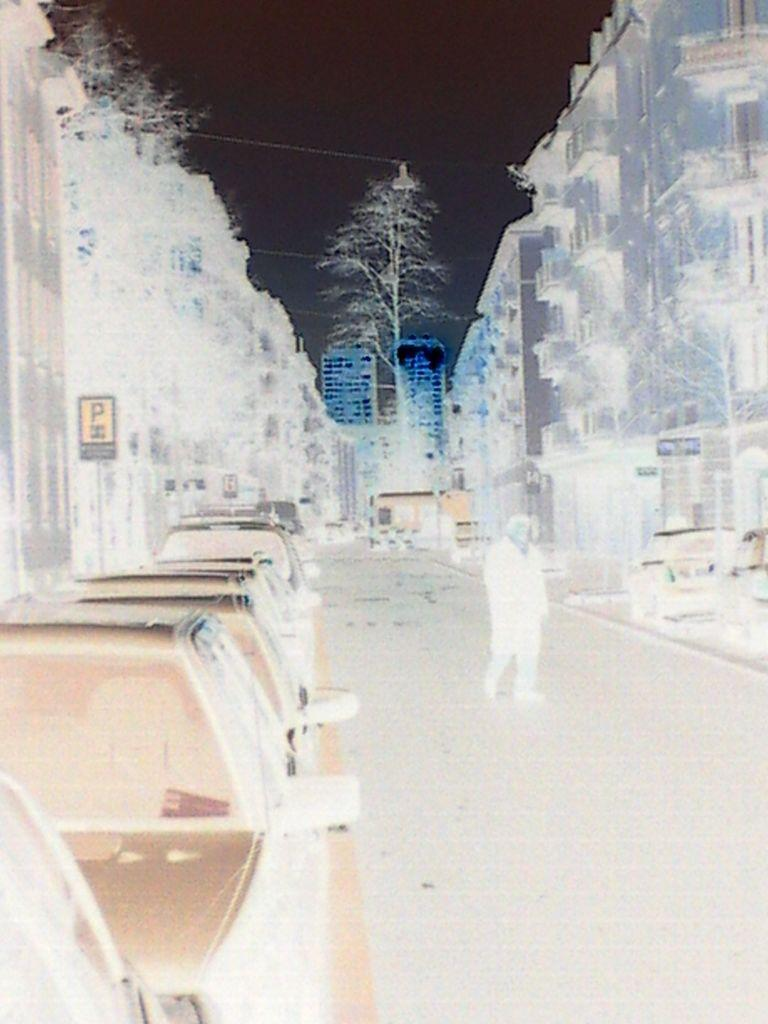What type of structures can be seen in the image? There are buildings in the image. What other natural elements are present in the image? There are trees in the image. Can you describe the lighting conditions in the image? There is light visible in the image. What part of the natural environment is visible in the image? The sky is visible in the image. What is the person in the image doing? The person is walking in the front of the image. What is the color scheme of the image? The image is in black and white. What type of fuel is being used by the iron in the image? There is no iron or fuel present in the image; it features buildings, trees, light, sky, and a person walking. What type of operation is being performed by the person in the image? The person in the image is simply walking, and no specific operation is being performed. 